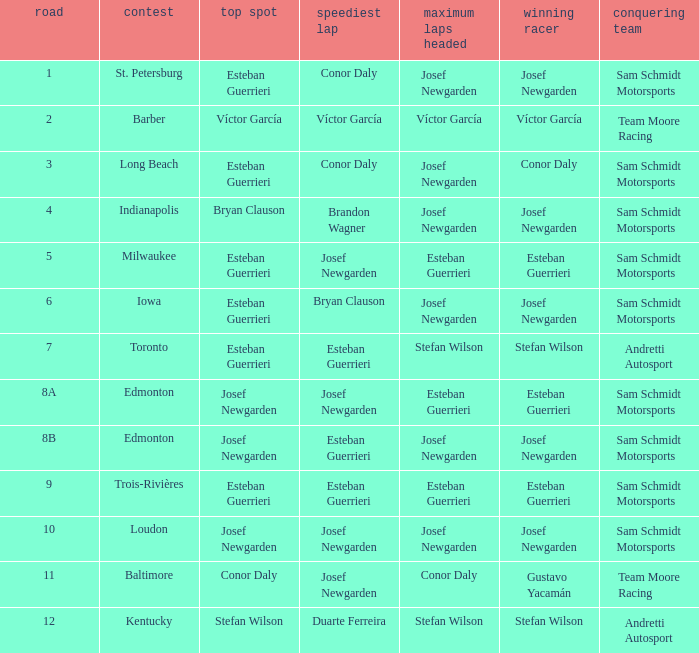Who led the most laps when brandon wagner had the fastest lap? Josef Newgarden. 